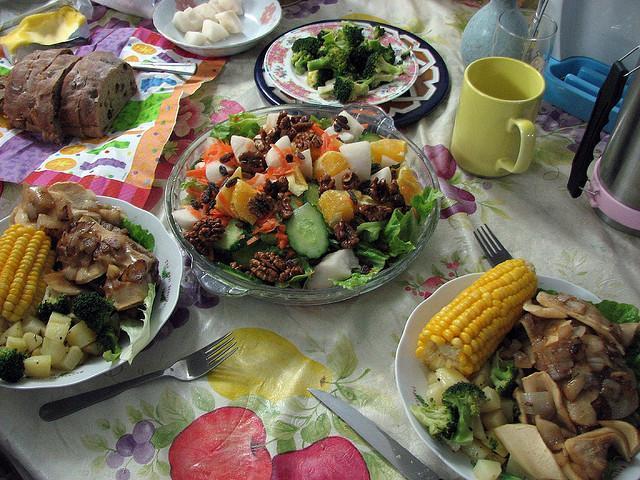How many ears of corn are there?
Give a very brief answer. 2. How many forks can be seen?
Give a very brief answer. 1. How many cups are in the picture?
Give a very brief answer. 2. How many bowls are there?
Give a very brief answer. 3. How many apples are in the photo?
Give a very brief answer. 2. How many horses in the photo?
Give a very brief answer. 0. 